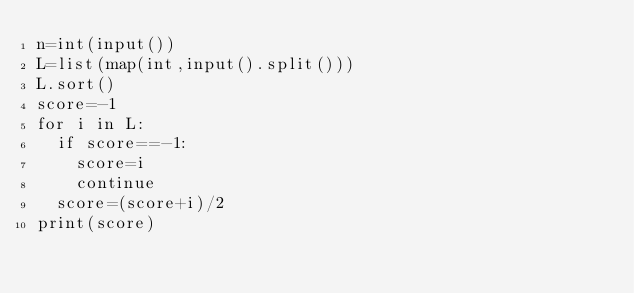Convert code to text. <code><loc_0><loc_0><loc_500><loc_500><_Python_>n=int(input())
L=list(map(int,input().split()))
L.sort()
score=-1
for i in L:
  if score==-1:
    score=i
    continue
  score=(score+i)/2
print(score)</code> 